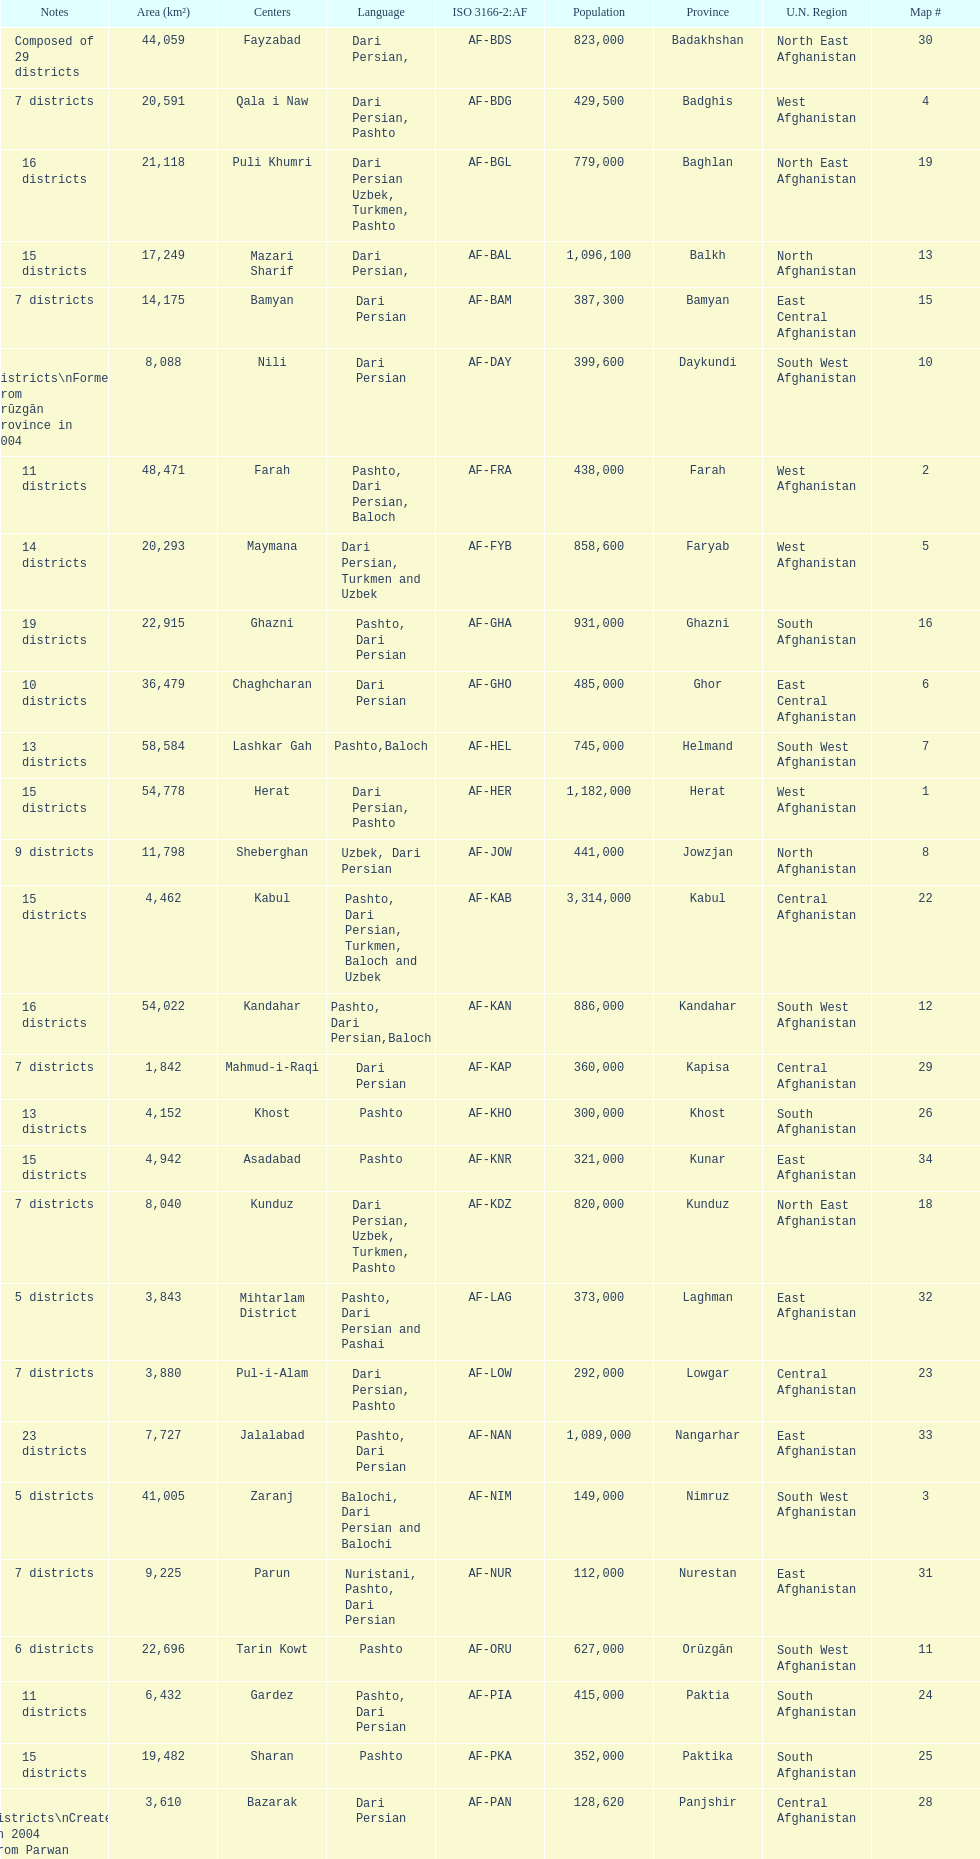What province is listed previous to ghor? Ghazni. 